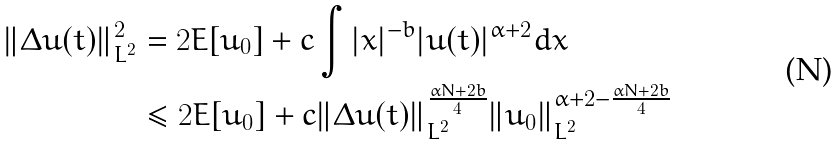Convert formula to latex. <formula><loc_0><loc_0><loc_500><loc_500>\| \Delta u ( t ) \| _ { L ^ { 2 } } ^ { 2 } & = 2 E [ u _ { 0 } ] + c \int | x | ^ { - b } | u ( t ) | ^ { \alpha + 2 } d x \\ & \leq 2 E [ u _ { 0 } ] + c \| \Delta u ( t ) \| _ { L ^ { 2 } } ^ { \frac { \alpha N + 2 b } { 4 } } \| u _ { 0 } \| _ { L ^ { 2 } } ^ { \alpha + 2 - \frac { \alpha N + 2 b } { 4 } }</formula> 